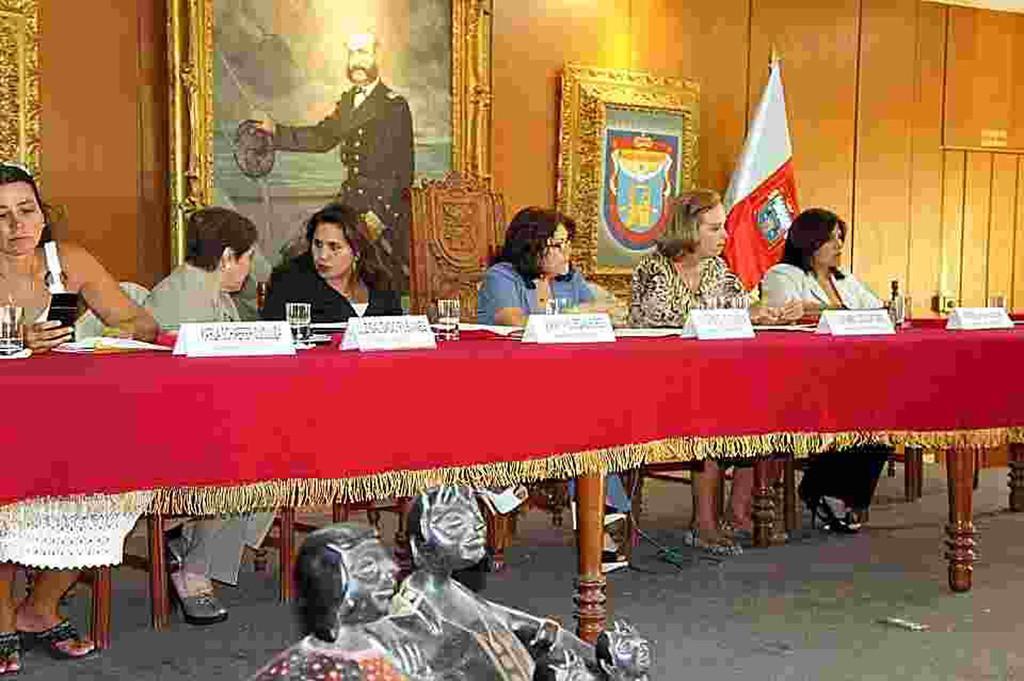Please provide a concise description of this image. There are some people sitting in the chairs in front of a table on which some name plates glasses and some papers were there. There is one photo frame attached to the wall. In the background there is a flag. All of them were women here. 